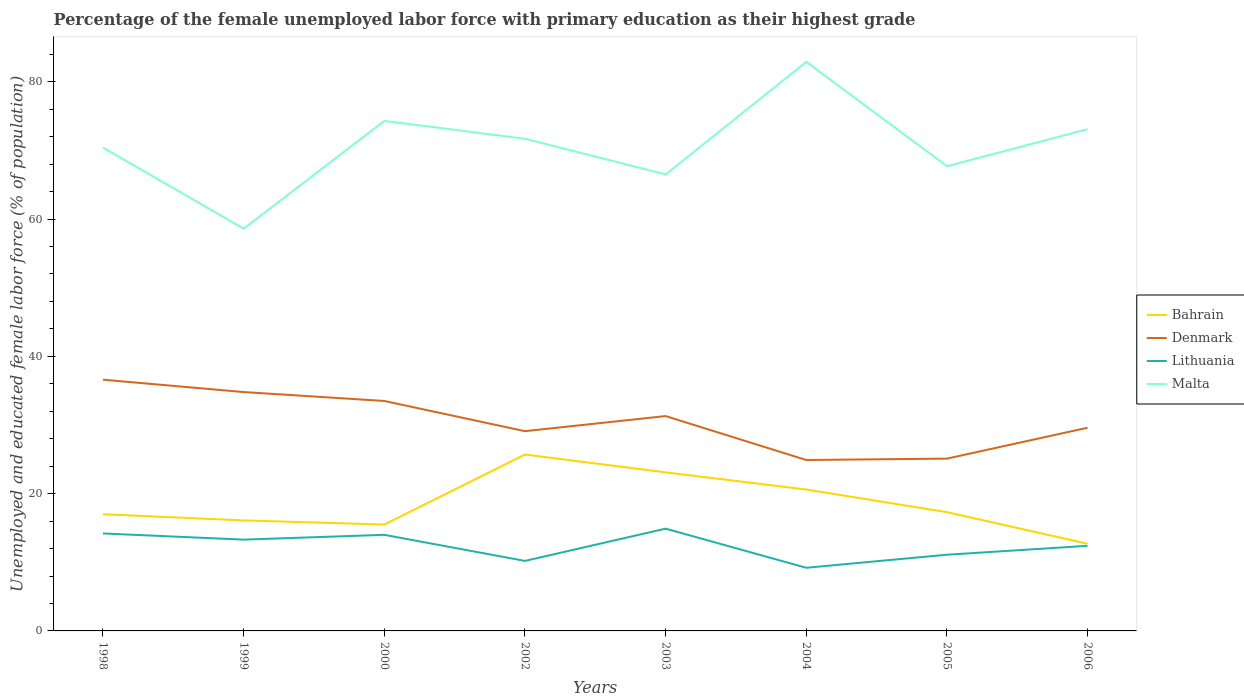How many different coloured lines are there?
Your response must be concise. 4. Across all years, what is the maximum percentage of the unemployed female labor force with primary education in Lithuania?
Make the answer very short. 9.2. In which year was the percentage of the unemployed female labor force with primary education in Malta maximum?
Your answer should be compact. 1999. What is the total percentage of the unemployed female labor force with primary education in Malta in the graph?
Offer a very short reply. -9.1. What is the difference between the highest and the second highest percentage of the unemployed female labor force with primary education in Denmark?
Provide a succinct answer. 11.7. What is the difference between the highest and the lowest percentage of the unemployed female labor force with primary education in Bahrain?
Offer a very short reply. 3. What is the difference between two consecutive major ticks on the Y-axis?
Your response must be concise. 20. Does the graph contain any zero values?
Give a very brief answer. No. What is the title of the graph?
Offer a terse response. Percentage of the female unemployed labor force with primary education as their highest grade. Does "Mali" appear as one of the legend labels in the graph?
Provide a short and direct response. No. What is the label or title of the Y-axis?
Ensure brevity in your answer.  Unemployed and educated female labor force (% of population). What is the Unemployed and educated female labor force (% of population) in Bahrain in 1998?
Offer a terse response. 17. What is the Unemployed and educated female labor force (% of population) in Denmark in 1998?
Give a very brief answer. 36.6. What is the Unemployed and educated female labor force (% of population) in Lithuania in 1998?
Ensure brevity in your answer.  14.2. What is the Unemployed and educated female labor force (% of population) of Malta in 1998?
Keep it short and to the point. 70.4. What is the Unemployed and educated female labor force (% of population) of Bahrain in 1999?
Your answer should be very brief. 16.1. What is the Unemployed and educated female labor force (% of population) in Denmark in 1999?
Offer a terse response. 34.8. What is the Unemployed and educated female labor force (% of population) in Lithuania in 1999?
Give a very brief answer. 13.3. What is the Unemployed and educated female labor force (% of population) of Malta in 1999?
Provide a short and direct response. 58.6. What is the Unemployed and educated female labor force (% of population) of Denmark in 2000?
Make the answer very short. 33.5. What is the Unemployed and educated female labor force (% of population) in Lithuania in 2000?
Give a very brief answer. 14. What is the Unemployed and educated female labor force (% of population) of Malta in 2000?
Provide a succinct answer. 74.3. What is the Unemployed and educated female labor force (% of population) in Bahrain in 2002?
Offer a very short reply. 25.7. What is the Unemployed and educated female labor force (% of population) in Denmark in 2002?
Make the answer very short. 29.1. What is the Unemployed and educated female labor force (% of population) in Lithuania in 2002?
Keep it short and to the point. 10.2. What is the Unemployed and educated female labor force (% of population) of Malta in 2002?
Your response must be concise. 71.7. What is the Unemployed and educated female labor force (% of population) of Bahrain in 2003?
Your answer should be compact. 23.1. What is the Unemployed and educated female labor force (% of population) in Denmark in 2003?
Your answer should be very brief. 31.3. What is the Unemployed and educated female labor force (% of population) in Lithuania in 2003?
Your answer should be very brief. 14.9. What is the Unemployed and educated female labor force (% of population) of Malta in 2003?
Offer a very short reply. 66.5. What is the Unemployed and educated female labor force (% of population) of Bahrain in 2004?
Offer a terse response. 20.6. What is the Unemployed and educated female labor force (% of population) of Denmark in 2004?
Your response must be concise. 24.9. What is the Unemployed and educated female labor force (% of population) in Lithuania in 2004?
Keep it short and to the point. 9.2. What is the Unemployed and educated female labor force (% of population) of Malta in 2004?
Give a very brief answer. 82.9. What is the Unemployed and educated female labor force (% of population) of Bahrain in 2005?
Your response must be concise. 17.3. What is the Unemployed and educated female labor force (% of population) of Denmark in 2005?
Provide a succinct answer. 25.1. What is the Unemployed and educated female labor force (% of population) of Lithuania in 2005?
Your answer should be compact. 11.1. What is the Unemployed and educated female labor force (% of population) in Malta in 2005?
Offer a terse response. 67.7. What is the Unemployed and educated female labor force (% of population) of Bahrain in 2006?
Ensure brevity in your answer.  12.7. What is the Unemployed and educated female labor force (% of population) of Denmark in 2006?
Give a very brief answer. 29.6. What is the Unemployed and educated female labor force (% of population) in Lithuania in 2006?
Provide a succinct answer. 12.4. What is the Unemployed and educated female labor force (% of population) in Malta in 2006?
Provide a succinct answer. 73.1. Across all years, what is the maximum Unemployed and educated female labor force (% of population) in Bahrain?
Offer a terse response. 25.7. Across all years, what is the maximum Unemployed and educated female labor force (% of population) in Denmark?
Provide a short and direct response. 36.6. Across all years, what is the maximum Unemployed and educated female labor force (% of population) of Lithuania?
Make the answer very short. 14.9. Across all years, what is the maximum Unemployed and educated female labor force (% of population) of Malta?
Your answer should be compact. 82.9. Across all years, what is the minimum Unemployed and educated female labor force (% of population) of Bahrain?
Provide a succinct answer. 12.7. Across all years, what is the minimum Unemployed and educated female labor force (% of population) of Denmark?
Make the answer very short. 24.9. Across all years, what is the minimum Unemployed and educated female labor force (% of population) in Lithuania?
Ensure brevity in your answer.  9.2. Across all years, what is the minimum Unemployed and educated female labor force (% of population) in Malta?
Provide a short and direct response. 58.6. What is the total Unemployed and educated female labor force (% of population) in Bahrain in the graph?
Your answer should be compact. 148. What is the total Unemployed and educated female labor force (% of population) in Denmark in the graph?
Your response must be concise. 244.9. What is the total Unemployed and educated female labor force (% of population) in Lithuania in the graph?
Your answer should be compact. 99.3. What is the total Unemployed and educated female labor force (% of population) in Malta in the graph?
Make the answer very short. 565.2. What is the difference between the Unemployed and educated female labor force (% of population) in Denmark in 1998 and that in 1999?
Your answer should be compact. 1.8. What is the difference between the Unemployed and educated female labor force (% of population) of Lithuania in 1998 and that in 1999?
Offer a very short reply. 0.9. What is the difference between the Unemployed and educated female labor force (% of population) of Malta in 1998 and that in 1999?
Make the answer very short. 11.8. What is the difference between the Unemployed and educated female labor force (% of population) in Bahrain in 1998 and that in 2000?
Your answer should be very brief. 1.5. What is the difference between the Unemployed and educated female labor force (% of population) of Malta in 1998 and that in 2000?
Make the answer very short. -3.9. What is the difference between the Unemployed and educated female labor force (% of population) of Bahrain in 1998 and that in 2002?
Keep it short and to the point. -8.7. What is the difference between the Unemployed and educated female labor force (% of population) of Denmark in 1998 and that in 2002?
Give a very brief answer. 7.5. What is the difference between the Unemployed and educated female labor force (% of population) of Denmark in 1998 and that in 2003?
Offer a very short reply. 5.3. What is the difference between the Unemployed and educated female labor force (% of population) of Bahrain in 1998 and that in 2004?
Offer a very short reply. -3.6. What is the difference between the Unemployed and educated female labor force (% of population) of Denmark in 1998 and that in 2004?
Your response must be concise. 11.7. What is the difference between the Unemployed and educated female labor force (% of population) of Lithuania in 1998 and that in 2004?
Provide a short and direct response. 5. What is the difference between the Unemployed and educated female labor force (% of population) of Lithuania in 1998 and that in 2005?
Your answer should be compact. 3.1. What is the difference between the Unemployed and educated female labor force (% of population) in Malta in 1998 and that in 2005?
Provide a succinct answer. 2.7. What is the difference between the Unemployed and educated female labor force (% of population) of Lithuania in 1998 and that in 2006?
Offer a terse response. 1.8. What is the difference between the Unemployed and educated female labor force (% of population) in Malta in 1998 and that in 2006?
Make the answer very short. -2.7. What is the difference between the Unemployed and educated female labor force (% of population) of Lithuania in 1999 and that in 2000?
Provide a succinct answer. -0.7. What is the difference between the Unemployed and educated female labor force (% of population) in Malta in 1999 and that in 2000?
Keep it short and to the point. -15.7. What is the difference between the Unemployed and educated female labor force (% of population) in Denmark in 1999 and that in 2002?
Your answer should be compact. 5.7. What is the difference between the Unemployed and educated female labor force (% of population) in Lithuania in 1999 and that in 2002?
Offer a terse response. 3.1. What is the difference between the Unemployed and educated female labor force (% of population) in Bahrain in 1999 and that in 2003?
Your response must be concise. -7. What is the difference between the Unemployed and educated female labor force (% of population) of Lithuania in 1999 and that in 2003?
Make the answer very short. -1.6. What is the difference between the Unemployed and educated female labor force (% of population) in Bahrain in 1999 and that in 2004?
Your answer should be very brief. -4.5. What is the difference between the Unemployed and educated female labor force (% of population) in Denmark in 1999 and that in 2004?
Your answer should be compact. 9.9. What is the difference between the Unemployed and educated female labor force (% of population) in Malta in 1999 and that in 2004?
Offer a terse response. -24.3. What is the difference between the Unemployed and educated female labor force (% of population) in Lithuania in 1999 and that in 2005?
Offer a very short reply. 2.2. What is the difference between the Unemployed and educated female labor force (% of population) of Malta in 1999 and that in 2005?
Your response must be concise. -9.1. What is the difference between the Unemployed and educated female labor force (% of population) of Denmark in 1999 and that in 2006?
Your answer should be very brief. 5.2. What is the difference between the Unemployed and educated female labor force (% of population) in Malta in 1999 and that in 2006?
Your answer should be compact. -14.5. What is the difference between the Unemployed and educated female labor force (% of population) in Lithuania in 2000 and that in 2002?
Your response must be concise. 3.8. What is the difference between the Unemployed and educated female labor force (% of population) of Malta in 2000 and that in 2002?
Keep it short and to the point. 2.6. What is the difference between the Unemployed and educated female labor force (% of population) of Bahrain in 2000 and that in 2003?
Offer a very short reply. -7.6. What is the difference between the Unemployed and educated female labor force (% of population) of Malta in 2000 and that in 2003?
Your answer should be very brief. 7.8. What is the difference between the Unemployed and educated female labor force (% of population) in Denmark in 2000 and that in 2004?
Offer a terse response. 8.6. What is the difference between the Unemployed and educated female labor force (% of population) in Lithuania in 2000 and that in 2004?
Provide a succinct answer. 4.8. What is the difference between the Unemployed and educated female labor force (% of population) of Malta in 2000 and that in 2004?
Give a very brief answer. -8.6. What is the difference between the Unemployed and educated female labor force (% of population) of Bahrain in 2000 and that in 2006?
Ensure brevity in your answer.  2.8. What is the difference between the Unemployed and educated female labor force (% of population) in Denmark in 2000 and that in 2006?
Offer a terse response. 3.9. What is the difference between the Unemployed and educated female labor force (% of population) of Lithuania in 2002 and that in 2003?
Keep it short and to the point. -4.7. What is the difference between the Unemployed and educated female labor force (% of population) of Malta in 2002 and that in 2003?
Offer a terse response. 5.2. What is the difference between the Unemployed and educated female labor force (% of population) of Denmark in 2002 and that in 2004?
Offer a very short reply. 4.2. What is the difference between the Unemployed and educated female labor force (% of population) in Denmark in 2002 and that in 2005?
Keep it short and to the point. 4. What is the difference between the Unemployed and educated female labor force (% of population) in Malta in 2002 and that in 2005?
Provide a succinct answer. 4. What is the difference between the Unemployed and educated female labor force (% of population) of Bahrain in 2002 and that in 2006?
Offer a terse response. 13. What is the difference between the Unemployed and educated female labor force (% of population) of Lithuania in 2002 and that in 2006?
Provide a succinct answer. -2.2. What is the difference between the Unemployed and educated female labor force (% of population) of Denmark in 2003 and that in 2004?
Keep it short and to the point. 6.4. What is the difference between the Unemployed and educated female labor force (% of population) of Lithuania in 2003 and that in 2004?
Your answer should be compact. 5.7. What is the difference between the Unemployed and educated female labor force (% of population) in Malta in 2003 and that in 2004?
Provide a short and direct response. -16.4. What is the difference between the Unemployed and educated female labor force (% of population) in Lithuania in 2003 and that in 2005?
Provide a succinct answer. 3.8. What is the difference between the Unemployed and educated female labor force (% of population) of Malta in 2003 and that in 2005?
Your answer should be very brief. -1.2. What is the difference between the Unemployed and educated female labor force (% of population) in Bahrain in 2004 and that in 2005?
Your response must be concise. 3.3. What is the difference between the Unemployed and educated female labor force (% of population) in Lithuania in 2004 and that in 2005?
Your response must be concise. -1.9. What is the difference between the Unemployed and educated female labor force (% of population) in Malta in 2004 and that in 2005?
Make the answer very short. 15.2. What is the difference between the Unemployed and educated female labor force (% of population) of Bahrain in 2004 and that in 2006?
Offer a terse response. 7.9. What is the difference between the Unemployed and educated female labor force (% of population) in Denmark in 2004 and that in 2006?
Provide a short and direct response. -4.7. What is the difference between the Unemployed and educated female labor force (% of population) in Lithuania in 2004 and that in 2006?
Your answer should be very brief. -3.2. What is the difference between the Unemployed and educated female labor force (% of population) in Bahrain in 2005 and that in 2006?
Ensure brevity in your answer.  4.6. What is the difference between the Unemployed and educated female labor force (% of population) of Denmark in 2005 and that in 2006?
Ensure brevity in your answer.  -4.5. What is the difference between the Unemployed and educated female labor force (% of population) in Bahrain in 1998 and the Unemployed and educated female labor force (% of population) in Denmark in 1999?
Provide a short and direct response. -17.8. What is the difference between the Unemployed and educated female labor force (% of population) in Bahrain in 1998 and the Unemployed and educated female labor force (% of population) in Malta in 1999?
Make the answer very short. -41.6. What is the difference between the Unemployed and educated female labor force (% of population) of Denmark in 1998 and the Unemployed and educated female labor force (% of population) of Lithuania in 1999?
Your answer should be very brief. 23.3. What is the difference between the Unemployed and educated female labor force (% of population) in Denmark in 1998 and the Unemployed and educated female labor force (% of population) in Malta in 1999?
Give a very brief answer. -22. What is the difference between the Unemployed and educated female labor force (% of population) of Lithuania in 1998 and the Unemployed and educated female labor force (% of population) of Malta in 1999?
Make the answer very short. -44.4. What is the difference between the Unemployed and educated female labor force (% of population) of Bahrain in 1998 and the Unemployed and educated female labor force (% of population) of Denmark in 2000?
Provide a succinct answer. -16.5. What is the difference between the Unemployed and educated female labor force (% of population) of Bahrain in 1998 and the Unemployed and educated female labor force (% of population) of Malta in 2000?
Ensure brevity in your answer.  -57.3. What is the difference between the Unemployed and educated female labor force (% of population) in Denmark in 1998 and the Unemployed and educated female labor force (% of population) in Lithuania in 2000?
Provide a succinct answer. 22.6. What is the difference between the Unemployed and educated female labor force (% of population) of Denmark in 1998 and the Unemployed and educated female labor force (% of population) of Malta in 2000?
Your response must be concise. -37.7. What is the difference between the Unemployed and educated female labor force (% of population) of Lithuania in 1998 and the Unemployed and educated female labor force (% of population) of Malta in 2000?
Ensure brevity in your answer.  -60.1. What is the difference between the Unemployed and educated female labor force (% of population) in Bahrain in 1998 and the Unemployed and educated female labor force (% of population) in Denmark in 2002?
Provide a short and direct response. -12.1. What is the difference between the Unemployed and educated female labor force (% of population) in Bahrain in 1998 and the Unemployed and educated female labor force (% of population) in Malta in 2002?
Offer a terse response. -54.7. What is the difference between the Unemployed and educated female labor force (% of population) of Denmark in 1998 and the Unemployed and educated female labor force (% of population) of Lithuania in 2002?
Offer a very short reply. 26.4. What is the difference between the Unemployed and educated female labor force (% of population) in Denmark in 1998 and the Unemployed and educated female labor force (% of population) in Malta in 2002?
Provide a short and direct response. -35.1. What is the difference between the Unemployed and educated female labor force (% of population) in Lithuania in 1998 and the Unemployed and educated female labor force (% of population) in Malta in 2002?
Keep it short and to the point. -57.5. What is the difference between the Unemployed and educated female labor force (% of population) in Bahrain in 1998 and the Unemployed and educated female labor force (% of population) in Denmark in 2003?
Offer a terse response. -14.3. What is the difference between the Unemployed and educated female labor force (% of population) in Bahrain in 1998 and the Unemployed and educated female labor force (% of population) in Lithuania in 2003?
Give a very brief answer. 2.1. What is the difference between the Unemployed and educated female labor force (% of population) in Bahrain in 1998 and the Unemployed and educated female labor force (% of population) in Malta in 2003?
Provide a succinct answer. -49.5. What is the difference between the Unemployed and educated female labor force (% of population) in Denmark in 1998 and the Unemployed and educated female labor force (% of population) in Lithuania in 2003?
Provide a short and direct response. 21.7. What is the difference between the Unemployed and educated female labor force (% of population) of Denmark in 1998 and the Unemployed and educated female labor force (% of population) of Malta in 2003?
Your response must be concise. -29.9. What is the difference between the Unemployed and educated female labor force (% of population) of Lithuania in 1998 and the Unemployed and educated female labor force (% of population) of Malta in 2003?
Offer a very short reply. -52.3. What is the difference between the Unemployed and educated female labor force (% of population) of Bahrain in 1998 and the Unemployed and educated female labor force (% of population) of Malta in 2004?
Provide a succinct answer. -65.9. What is the difference between the Unemployed and educated female labor force (% of population) of Denmark in 1998 and the Unemployed and educated female labor force (% of population) of Lithuania in 2004?
Your answer should be compact. 27.4. What is the difference between the Unemployed and educated female labor force (% of population) of Denmark in 1998 and the Unemployed and educated female labor force (% of population) of Malta in 2004?
Provide a succinct answer. -46.3. What is the difference between the Unemployed and educated female labor force (% of population) of Lithuania in 1998 and the Unemployed and educated female labor force (% of population) of Malta in 2004?
Make the answer very short. -68.7. What is the difference between the Unemployed and educated female labor force (% of population) in Bahrain in 1998 and the Unemployed and educated female labor force (% of population) in Denmark in 2005?
Your answer should be very brief. -8.1. What is the difference between the Unemployed and educated female labor force (% of population) of Bahrain in 1998 and the Unemployed and educated female labor force (% of population) of Lithuania in 2005?
Your response must be concise. 5.9. What is the difference between the Unemployed and educated female labor force (% of population) of Bahrain in 1998 and the Unemployed and educated female labor force (% of population) of Malta in 2005?
Offer a very short reply. -50.7. What is the difference between the Unemployed and educated female labor force (% of population) of Denmark in 1998 and the Unemployed and educated female labor force (% of population) of Malta in 2005?
Offer a very short reply. -31.1. What is the difference between the Unemployed and educated female labor force (% of population) in Lithuania in 1998 and the Unemployed and educated female labor force (% of population) in Malta in 2005?
Your response must be concise. -53.5. What is the difference between the Unemployed and educated female labor force (% of population) in Bahrain in 1998 and the Unemployed and educated female labor force (% of population) in Lithuania in 2006?
Provide a short and direct response. 4.6. What is the difference between the Unemployed and educated female labor force (% of population) of Bahrain in 1998 and the Unemployed and educated female labor force (% of population) of Malta in 2006?
Offer a terse response. -56.1. What is the difference between the Unemployed and educated female labor force (% of population) in Denmark in 1998 and the Unemployed and educated female labor force (% of population) in Lithuania in 2006?
Your answer should be compact. 24.2. What is the difference between the Unemployed and educated female labor force (% of population) in Denmark in 1998 and the Unemployed and educated female labor force (% of population) in Malta in 2006?
Keep it short and to the point. -36.5. What is the difference between the Unemployed and educated female labor force (% of population) of Lithuania in 1998 and the Unemployed and educated female labor force (% of population) of Malta in 2006?
Make the answer very short. -58.9. What is the difference between the Unemployed and educated female labor force (% of population) in Bahrain in 1999 and the Unemployed and educated female labor force (% of population) in Denmark in 2000?
Your response must be concise. -17.4. What is the difference between the Unemployed and educated female labor force (% of population) of Bahrain in 1999 and the Unemployed and educated female labor force (% of population) of Malta in 2000?
Keep it short and to the point. -58.2. What is the difference between the Unemployed and educated female labor force (% of population) of Denmark in 1999 and the Unemployed and educated female labor force (% of population) of Lithuania in 2000?
Keep it short and to the point. 20.8. What is the difference between the Unemployed and educated female labor force (% of population) of Denmark in 1999 and the Unemployed and educated female labor force (% of population) of Malta in 2000?
Give a very brief answer. -39.5. What is the difference between the Unemployed and educated female labor force (% of population) of Lithuania in 1999 and the Unemployed and educated female labor force (% of population) of Malta in 2000?
Offer a very short reply. -61. What is the difference between the Unemployed and educated female labor force (% of population) of Bahrain in 1999 and the Unemployed and educated female labor force (% of population) of Denmark in 2002?
Your answer should be compact. -13. What is the difference between the Unemployed and educated female labor force (% of population) of Bahrain in 1999 and the Unemployed and educated female labor force (% of population) of Malta in 2002?
Give a very brief answer. -55.6. What is the difference between the Unemployed and educated female labor force (% of population) of Denmark in 1999 and the Unemployed and educated female labor force (% of population) of Lithuania in 2002?
Your response must be concise. 24.6. What is the difference between the Unemployed and educated female labor force (% of population) of Denmark in 1999 and the Unemployed and educated female labor force (% of population) of Malta in 2002?
Provide a short and direct response. -36.9. What is the difference between the Unemployed and educated female labor force (% of population) of Lithuania in 1999 and the Unemployed and educated female labor force (% of population) of Malta in 2002?
Ensure brevity in your answer.  -58.4. What is the difference between the Unemployed and educated female labor force (% of population) in Bahrain in 1999 and the Unemployed and educated female labor force (% of population) in Denmark in 2003?
Give a very brief answer. -15.2. What is the difference between the Unemployed and educated female labor force (% of population) in Bahrain in 1999 and the Unemployed and educated female labor force (% of population) in Lithuania in 2003?
Offer a terse response. 1.2. What is the difference between the Unemployed and educated female labor force (% of population) of Bahrain in 1999 and the Unemployed and educated female labor force (% of population) of Malta in 2003?
Keep it short and to the point. -50.4. What is the difference between the Unemployed and educated female labor force (% of population) in Denmark in 1999 and the Unemployed and educated female labor force (% of population) in Malta in 2003?
Give a very brief answer. -31.7. What is the difference between the Unemployed and educated female labor force (% of population) of Lithuania in 1999 and the Unemployed and educated female labor force (% of population) of Malta in 2003?
Provide a short and direct response. -53.2. What is the difference between the Unemployed and educated female labor force (% of population) in Bahrain in 1999 and the Unemployed and educated female labor force (% of population) in Malta in 2004?
Your answer should be compact. -66.8. What is the difference between the Unemployed and educated female labor force (% of population) in Denmark in 1999 and the Unemployed and educated female labor force (% of population) in Lithuania in 2004?
Provide a succinct answer. 25.6. What is the difference between the Unemployed and educated female labor force (% of population) in Denmark in 1999 and the Unemployed and educated female labor force (% of population) in Malta in 2004?
Provide a short and direct response. -48.1. What is the difference between the Unemployed and educated female labor force (% of population) of Lithuania in 1999 and the Unemployed and educated female labor force (% of population) of Malta in 2004?
Provide a succinct answer. -69.6. What is the difference between the Unemployed and educated female labor force (% of population) of Bahrain in 1999 and the Unemployed and educated female labor force (% of population) of Malta in 2005?
Ensure brevity in your answer.  -51.6. What is the difference between the Unemployed and educated female labor force (% of population) of Denmark in 1999 and the Unemployed and educated female labor force (% of population) of Lithuania in 2005?
Ensure brevity in your answer.  23.7. What is the difference between the Unemployed and educated female labor force (% of population) in Denmark in 1999 and the Unemployed and educated female labor force (% of population) in Malta in 2005?
Your response must be concise. -32.9. What is the difference between the Unemployed and educated female labor force (% of population) of Lithuania in 1999 and the Unemployed and educated female labor force (% of population) of Malta in 2005?
Make the answer very short. -54.4. What is the difference between the Unemployed and educated female labor force (% of population) in Bahrain in 1999 and the Unemployed and educated female labor force (% of population) in Malta in 2006?
Keep it short and to the point. -57. What is the difference between the Unemployed and educated female labor force (% of population) of Denmark in 1999 and the Unemployed and educated female labor force (% of population) of Lithuania in 2006?
Make the answer very short. 22.4. What is the difference between the Unemployed and educated female labor force (% of population) of Denmark in 1999 and the Unemployed and educated female labor force (% of population) of Malta in 2006?
Offer a very short reply. -38.3. What is the difference between the Unemployed and educated female labor force (% of population) in Lithuania in 1999 and the Unemployed and educated female labor force (% of population) in Malta in 2006?
Provide a short and direct response. -59.8. What is the difference between the Unemployed and educated female labor force (% of population) of Bahrain in 2000 and the Unemployed and educated female labor force (% of population) of Lithuania in 2002?
Your answer should be very brief. 5.3. What is the difference between the Unemployed and educated female labor force (% of population) of Bahrain in 2000 and the Unemployed and educated female labor force (% of population) of Malta in 2002?
Offer a very short reply. -56.2. What is the difference between the Unemployed and educated female labor force (% of population) of Denmark in 2000 and the Unemployed and educated female labor force (% of population) of Lithuania in 2002?
Give a very brief answer. 23.3. What is the difference between the Unemployed and educated female labor force (% of population) of Denmark in 2000 and the Unemployed and educated female labor force (% of population) of Malta in 2002?
Ensure brevity in your answer.  -38.2. What is the difference between the Unemployed and educated female labor force (% of population) in Lithuania in 2000 and the Unemployed and educated female labor force (% of population) in Malta in 2002?
Offer a terse response. -57.7. What is the difference between the Unemployed and educated female labor force (% of population) in Bahrain in 2000 and the Unemployed and educated female labor force (% of population) in Denmark in 2003?
Offer a very short reply. -15.8. What is the difference between the Unemployed and educated female labor force (% of population) in Bahrain in 2000 and the Unemployed and educated female labor force (% of population) in Lithuania in 2003?
Provide a short and direct response. 0.6. What is the difference between the Unemployed and educated female labor force (% of population) in Bahrain in 2000 and the Unemployed and educated female labor force (% of population) in Malta in 2003?
Your answer should be compact. -51. What is the difference between the Unemployed and educated female labor force (% of population) of Denmark in 2000 and the Unemployed and educated female labor force (% of population) of Malta in 2003?
Keep it short and to the point. -33. What is the difference between the Unemployed and educated female labor force (% of population) of Lithuania in 2000 and the Unemployed and educated female labor force (% of population) of Malta in 2003?
Your answer should be very brief. -52.5. What is the difference between the Unemployed and educated female labor force (% of population) of Bahrain in 2000 and the Unemployed and educated female labor force (% of population) of Denmark in 2004?
Give a very brief answer. -9.4. What is the difference between the Unemployed and educated female labor force (% of population) of Bahrain in 2000 and the Unemployed and educated female labor force (% of population) of Lithuania in 2004?
Provide a short and direct response. 6.3. What is the difference between the Unemployed and educated female labor force (% of population) of Bahrain in 2000 and the Unemployed and educated female labor force (% of population) of Malta in 2004?
Offer a very short reply. -67.4. What is the difference between the Unemployed and educated female labor force (% of population) in Denmark in 2000 and the Unemployed and educated female labor force (% of population) in Lithuania in 2004?
Offer a terse response. 24.3. What is the difference between the Unemployed and educated female labor force (% of population) of Denmark in 2000 and the Unemployed and educated female labor force (% of population) of Malta in 2004?
Give a very brief answer. -49.4. What is the difference between the Unemployed and educated female labor force (% of population) of Lithuania in 2000 and the Unemployed and educated female labor force (% of population) of Malta in 2004?
Your answer should be very brief. -68.9. What is the difference between the Unemployed and educated female labor force (% of population) in Bahrain in 2000 and the Unemployed and educated female labor force (% of population) in Denmark in 2005?
Offer a very short reply. -9.6. What is the difference between the Unemployed and educated female labor force (% of population) of Bahrain in 2000 and the Unemployed and educated female labor force (% of population) of Lithuania in 2005?
Ensure brevity in your answer.  4.4. What is the difference between the Unemployed and educated female labor force (% of population) in Bahrain in 2000 and the Unemployed and educated female labor force (% of population) in Malta in 2005?
Keep it short and to the point. -52.2. What is the difference between the Unemployed and educated female labor force (% of population) in Denmark in 2000 and the Unemployed and educated female labor force (% of population) in Lithuania in 2005?
Offer a very short reply. 22.4. What is the difference between the Unemployed and educated female labor force (% of population) in Denmark in 2000 and the Unemployed and educated female labor force (% of population) in Malta in 2005?
Your response must be concise. -34.2. What is the difference between the Unemployed and educated female labor force (% of population) in Lithuania in 2000 and the Unemployed and educated female labor force (% of population) in Malta in 2005?
Your answer should be compact. -53.7. What is the difference between the Unemployed and educated female labor force (% of population) in Bahrain in 2000 and the Unemployed and educated female labor force (% of population) in Denmark in 2006?
Offer a terse response. -14.1. What is the difference between the Unemployed and educated female labor force (% of population) in Bahrain in 2000 and the Unemployed and educated female labor force (% of population) in Malta in 2006?
Make the answer very short. -57.6. What is the difference between the Unemployed and educated female labor force (% of population) of Denmark in 2000 and the Unemployed and educated female labor force (% of population) of Lithuania in 2006?
Offer a very short reply. 21.1. What is the difference between the Unemployed and educated female labor force (% of population) in Denmark in 2000 and the Unemployed and educated female labor force (% of population) in Malta in 2006?
Your answer should be compact. -39.6. What is the difference between the Unemployed and educated female labor force (% of population) in Lithuania in 2000 and the Unemployed and educated female labor force (% of population) in Malta in 2006?
Your answer should be compact. -59.1. What is the difference between the Unemployed and educated female labor force (% of population) of Bahrain in 2002 and the Unemployed and educated female labor force (% of population) of Denmark in 2003?
Provide a short and direct response. -5.6. What is the difference between the Unemployed and educated female labor force (% of population) in Bahrain in 2002 and the Unemployed and educated female labor force (% of population) in Malta in 2003?
Give a very brief answer. -40.8. What is the difference between the Unemployed and educated female labor force (% of population) in Denmark in 2002 and the Unemployed and educated female labor force (% of population) in Malta in 2003?
Offer a terse response. -37.4. What is the difference between the Unemployed and educated female labor force (% of population) of Lithuania in 2002 and the Unemployed and educated female labor force (% of population) of Malta in 2003?
Offer a terse response. -56.3. What is the difference between the Unemployed and educated female labor force (% of population) in Bahrain in 2002 and the Unemployed and educated female labor force (% of population) in Malta in 2004?
Provide a short and direct response. -57.2. What is the difference between the Unemployed and educated female labor force (% of population) in Denmark in 2002 and the Unemployed and educated female labor force (% of population) in Lithuania in 2004?
Ensure brevity in your answer.  19.9. What is the difference between the Unemployed and educated female labor force (% of population) in Denmark in 2002 and the Unemployed and educated female labor force (% of population) in Malta in 2004?
Your answer should be compact. -53.8. What is the difference between the Unemployed and educated female labor force (% of population) of Lithuania in 2002 and the Unemployed and educated female labor force (% of population) of Malta in 2004?
Ensure brevity in your answer.  -72.7. What is the difference between the Unemployed and educated female labor force (% of population) of Bahrain in 2002 and the Unemployed and educated female labor force (% of population) of Denmark in 2005?
Offer a very short reply. 0.6. What is the difference between the Unemployed and educated female labor force (% of population) of Bahrain in 2002 and the Unemployed and educated female labor force (% of population) of Lithuania in 2005?
Offer a terse response. 14.6. What is the difference between the Unemployed and educated female labor force (% of population) in Bahrain in 2002 and the Unemployed and educated female labor force (% of population) in Malta in 2005?
Your answer should be compact. -42. What is the difference between the Unemployed and educated female labor force (% of population) of Denmark in 2002 and the Unemployed and educated female labor force (% of population) of Lithuania in 2005?
Your response must be concise. 18. What is the difference between the Unemployed and educated female labor force (% of population) in Denmark in 2002 and the Unemployed and educated female labor force (% of population) in Malta in 2005?
Ensure brevity in your answer.  -38.6. What is the difference between the Unemployed and educated female labor force (% of population) in Lithuania in 2002 and the Unemployed and educated female labor force (% of population) in Malta in 2005?
Give a very brief answer. -57.5. What is the difference between the Unemployed and educated female labor force (% of population) of Bahrain in 2002 and the Unemployed and educated female labor force (% of population) of Denmark in 2006?
Your answer should be very brief. -3.9. What is the difference between the Unemployed and educated female labor force (% of population) of Bahrain in 2002 and the Unemployed and educated female labor force (% of population) of Malta in 2006?
Ensure brevity in your answer.  -47.4. What is the difference between the Unemployed and educated female labor force (% of population) of Denmark in 2002 and the Unemployed and educated female labor force (% of population) of Malta in 2006?
Provide a succinct answer. -44. What is the difference between the Unemployed and educated female labor force (% of population) of Lithuania in 2002 and the Unemployed and educated female labor force (% of population) of Malta in 2006?
Offer a terse response. -62.9. What is the difference between the Unemployed and educated female labor force (% of population) of Bahrain in 2003 and the Unemployed and educated female labor force (% of population) of Denmark in 2004?
Your answer should be very brief. -1.8. What is the difference between the Unemployed and educated female labor force (% of population) of Bahrain in 2003 and the Unemployed and educated female labor force (% of population) of Lithuania in 2004?
Give a very brief answer. 13.9. What is the difference between the Unemployed and educated female labor force (% of population) in Bahrain in 2003 and the Unemployed and educated female labor force (% of population) in Malta in 2004?
Offer a very short reply. -59.8. What is the difference between the Unemployed and educated female labor force (% of population) of Denmark in 2003 and the Unemployed and educated female labor force (% of population) of Lithuania in 2004?
Keep it short and to the point. 22.1. What is the difference between the Unemployed and educated female labor force (% of population) of Denmark in 2003 and the Unemployed and educated female labor force (% of population) of Malta in 2004?
Offer a very short reply. -51.6. What is the difference between the Unemployed and educated female labor force (% of population) of Lithuania in 2003 and the Unemployed and educated female labor force (% of population) of Malta in 2004?
Your response must be concise. -68. What is the difference between the Unemployed and educated female labor force (% of population) in Bahrain in 2003 and the Unemployed and educated female labor force (% of population) in Denmark in 2005?
Ensure brevity in your answer.  -2. What is the difference between the Unemployed and educated female labor force (% of population) in Bahrain in 2003 and the Unemployed and educated female labor force (% of population) in Malta in 2005?
Provide a succinct answer. -44.6. What is the difference between the Unemployed and educated female labor force (% of population) of Denmark in 2003 and the Unemployed and educated female labor force (% of population) of Lithuania in 2005?
Ensure brevity in your answer.  20.2. What is the difference between the Unemployed and educated female labor force (% of population) in Denmark in 2003 and the Unemployed and educated female labor force (% of population) in Malta in 2005?
Make the answer very short. -36.4. What is the difference between the Unemployed and educated female labor force (% of population) in Lithuania in 2003 and the Unemployed and educated female labor force (% of population) in Malta in 2005?
Give a very brief answer. -52.8. What is the difference between the Unemployed and educated female labor force (% of population) in Bahrain in 2003 and the Unemployed and educated female labor force (% of population) in Denmark in 2006?
Provide a short and direct response. -6.5. What is the difference between the Unemployed and educated female labor force (% of population) of Bahrain in 2003 and the Unemployed and educated female labor force (% of population) of Lithuania in 2006?
Your response must be concise. 10.7. What is the difference between the Unemployed and educated female labor force (% of population) in Bahrain in 2003 and the Unemployed and educated female labor force (% of population) in Malta in 2006?
Make the answer very short. -50. What is the difference between the Unemployed and educated female labor force (% of population) in Denmark in 2003 and the Unemployed and educated female labor force (% of population) in Malta in 2006?
Your answer should be compact. -41.8. What is the difference between the Unemployed and educated female labor force (% of population) in Lithuania in 2003 and the Unemployed and educated female labor force (% of population) in Malta in 2006?
Offer a very short reply. -58.2. What is the difference between the Unemployed and educated female labor force (% of population) in Bahrain in 2004 and the Unemployed and educated female labor force (% of population) in Denmark in 2005?
Your answer should be very brief. -4.5. What is the difference between the Unemployed and educated female labor force (% of population) of Bahrain in 2004 and the Unemployed and educated female labor force (% of population) of Lithuania in 2005?
Ensure brevity in your answer.  9.5. What is the difference between the Unemployed and educated female labor force (% of population) of Bahrain in 2004 and the Unemployed and educated female labor force (% of population) of Malta in 2005?
Your answer should be very brief. -47.1. What is the difference between the Unemployed and educated female labor force (% of population) of Denmark in 2004 and the Unemployed and educated female labor force (% of population) of Lithuania in 2005?
Make the answer very short. 13.8. What is the difference between the Unemployed and educated female labor force (% of population) in Denmark in 2004 and the Unemployed and educated female labor force (% of population) in Malta in 2005?
Your answer should be compact. -42.8. What is the difference between the Unemployed and educated female labor force (% of population) in Lithuania in 2004 and the Unemployed and educated female labor force (% of population) in Malta in 2005?
Keep it short and to the point. -58.5. What is the difference between the Unemployed and educated female labor force (% of population) in Bahrain in 2004 and the Unemployed and educated female labor force (% of population) in Denmark in 2006?
Ensure brevity in your answer.  -9. What is the difference between the Unemployed and educated female labor force (% of population) of Bahrain in 2004 and the Unemployed and educated female labor force (% of population) of Lithuania in 2006?
Ensure brevity in your answer.  8.2. What is the difference between the Unemployed and educated female labor force (% of population) of Bahrain in 2004 and the Unemployed and educated female labor force (% of population) of Malta in 2006?
Offer a terse response. -52.5. What is the difference between the Unemployed and educated female labor force (% of population) in Denmark in 2004 and the Unemployed and educated female labor force (% of population) in Malta in 2006?
Your answer should be compact. -48.2. What is the difference between the Unemployed and educated female labor force (% of population) of Lithuania in 2004 and the Unemployed and educated female labor force (% of population) of Malta in 2006?
Keep it short and to the point. -63.9. What is the difference between the Unemployed and educated female labor force (% of population) of Bahrain in 2005 and the Unemployed and educated female labor force (% of population) of Denmark in 2006?
Ensure brevity in your answer.  -12.3. What is the difference between the Unemployed and educated female labor force (% of population) of Bahrain in 2005 and the Unemployed and educated female labor force (% of population) of Lithuania in 2006?
Provide a short and direct response. 4.9. What is the difference between the Unemployed and educated female labor force (% of population) of Bahrain in 2005 and the Unemployed and educated female labor force (% of population) of Malta in 2006?
Your answer should be compact. -55.8. What is the difference between the Unemployed and educated female labor force (% of population) in Denmark in 2005 and the Unemployed and educated female labor force (% of population) in Lithuania in 2006?
Provide a short and direct response. 12.7. What is the difference between the Unemployed and educated female labor force (% of population) of Denmark in 2005 and the Unemployed and educated female labor force (% of population) of Malta in 2006?
Give a very brief answer. -48. What is the difference between the Unemployed and educated female labor force (% of population) in Lithuania in 2005 and the Unemployed and educated female labor force (% of population) in Malta in 2006?
Provide a succinct answer. -62. What is the average Unemployed and educated female labor force (% of population) in Denmark per year?
Keep it short and to the point. 30.61. What is the average Unemployed and educated female labor force (% of population) of Lithuania per year?
Provide a succinct answer. 12.41. What is the average Unemployed and educated female labor force (% of population) in Malta per year?
Offer a very short reply. 70.65. In the year 1998, what is the difference between the Unemployed and educated female labor force (% of population) of Bahrain and Unemployed and educated female labor force (% of population) of Denmark?
Provide a short and direct response. -19.6. In the year 1998, what is the difference between the Unemployed and educated female labor force (% of population) of Bahrain and Unemployed and educated female labor force (% of population) of Lithuania?
Provide a short and direct response. 2.8. In the year 1998, what is the difference between the Unemployed and educated female labor force (% of population) in Bahrain and Unemployed and educated female labor force (% of population) in Malta?
Give a very brief answer. -53.4. In the year 1998, what is the difference between the Unemployed and educated female labor force (% of population) of Denmark and Unemployed and educated female labor force (% of population) of Lithuania?
Your answer should be very brief. 22.4. In the year 1998, what is the difference between the Unemployed and educated female labor force (% of population) of Denmark and Unemployed and educated female labor force (% of population) of Malta?
Provide a succinct answer. -33.8. In the year 1998, what is the difference between the Unemployed and educated female labor force (% of population) of Lithuania and Unemployed and educated female labor force (% of population) of Malta?
Offer a very short reply. -56.2. In the year 1999, what is the difference between the Unemployed and educated female labor force (% of population) of Bahrain and Unemployed and educated female labor force (% of population) of Denmark?
Keep it short and to the point. -18.7. In the year 1999, what is the difference between the Unemployed and educated female labor force (% of population) of Bahrain and Unemployed and educated female labor force (% of population) of Lithuania?
Offer a very short reply. 2.8. In the year 1999, what is the difference between the Unemployed and educated female labor force (% of population) of Bahrain and Unemployed and educated female labor force (% of population) of Malta?
Your answer should be compact. -42.5. In the year 1999, what is the difference between the Unemployed and educated female labor force (% of population) of Denmark and Unemployed and educated female labor force (% of population) of Malta?
Ensure brevity in your answer.  -23.8. In the year 1999, what is the difference between the Unemployed and educated female labor force (% of population) in Lithuania and Unemployed and educated female labor force (% of population) in Malta?
Provide a succinct answer. -45.3. In the year 2000, what is the difference between the Unemployed and educated female labor force (% of population) in Bahrain and Unemployed and educated female labor force (% of population) in Denmark?
Offer a very short reply. -18. In the year 2000, what is the difference between the Unemployed and educated female labor force (% of population) in Bahrain and Unemployed and educated female labor force (% of population) in Malta?
Give a very brief answer. -58.8. In the year 2000, what is the difference between the Unemployed and educated female labor force (% of population) of Denmark and Unemployed and educated female labor force (% of population) of Lithuania?
Provide a succinct answer. 19.5. In the year 2000, what is the difference between the Unemployed and educated female labor force (% of population) in Denmark and Unemployed and educated female labor force (% of population) in Malta?
Make the answer very short. -40.8. In the year 2000, what is the difference between the Unemployed and educated female labor force (% of population) in Lithuania and Unemployed and educated female labor force (% of population) in Malta?
Make the answer very short. -60.3. In the year 2002, what is the difference between the Unemployed and educated female labor force (% of population) of Bahrain and Unemployed and educated female labor force (% of population) of Denmark?
Offer a very short reply. -3.4. In the year 2002, what is the difference between the Unemployed and educated female labor force (% of population) of Bahrain and Unemployed and educated female labor force (% of population) of Malta?
Give a very brief answer. -46. In the year 2002, what is the difference between the Unemployed and educated female labor force (% of population) in Denmark and Unemployed and educated female labor force (% of population) in Malta?
Provide a succinct answer. -42.6. In the year 2002, what is the difference between the Unemployed and educated female labor force (% of population) in Lithuania and Unemployed and educated female labor force (% of population) in Malta?
Provide a short and direct response. -61.5. In the year 2003, what is the difference between the Unemployed and educated female labor force (% of population) of Bahrain and Unemployed and educated female labor force (% of population) of Lithuania?
Ensure brevity in your answer.  8.2. In the year 2003, what is the difference between the Unemployed and educated female labor force (% of population) in Bahrain and Unemployed and educated female labor force (% of population) in Malta?
Your answer should be very brief. -43.4. In the year 2003, what is the difference between the Unemployed and educated female labor force (% of population) of Denmark and Unemployed and educated female labor force (% of population) of Lithuania?
Make the answer very short. 16.4. In the year 2003, what is the difference between the Unemployed and educated female labor force (% of population) in Denmark and Unemployed and educated female labor force (% of population) in Malta?
Your response must be concise. -35.2. In the year 2003, what is the difference between the Unemployed and educated female labor force (% of population) in Lithuania and Unemployed and educated female labor force (% of population) in Malta?
Make the answer very short. -51.6. In the year 2004, what is the difference between the Unemployed and educated female labor force (% of population) of Bahrain and Unemployed and educated female labor force (% of population) of Lithuania?
Your response must be concise. 11.4. In the year 2004, what is the difference between the Unemployed and educated female labor force (% of population) in Bahrain and Unemployed and educated female labor force (% of population) in Malta?
Your answer should be very brief. -62.3. In the year 2004, what is the difference between the Unemployed and educated female labor force (% of population) of Denmark and Unemployed and educated female labor force (% of population) of Malta?
Your response must be concise. -58. In the year 2004, what is the difference between the Unemployed and educated female labor force (% of population) in Lithuania and Unemployed and educated female labor force (% of population) in Malta?
Ensure brevity in your answer.  -73.7. In the year 2005, what is the difference between the Unemployed and educated female labor force (% of population) in Bahrain and Unemployed and educated female labor force (% of population) in Malta?
Make the answer very short. -50.4. In the year 2005, what is the difference between the Unemployed and educated female labor force (% of population) in Denmark and Unemployed and educated female labor force (% of population) in Malta?
Your answer should be compact. -42.6. In the year 2005, what is the difference between the Unemployed and educated female labor force (% of population) in Lithuania and Unemployed and educated female labor force (% of population) in Malta?
Ensure brevity in your answer.  -56.6. In the year 2006, what is the difference between the Unemployed and educated female labor force (% of population) of Bahrain and Unemployed and educated female labor force (% of population) of Denmark?
Your answer should be compact. -16.9. In the year 2006, what is the difference between the Unemployed and educated female labor force (% of population) in Bahrain and Unemployed and educated female labor force (% of population) in Malta?
Your answer should be compact. -60.4. In the year 2006, what is the difference between the Unemployed and educated female labor force (% of population) of Denmark and Unemployed and educated female labor force (% of population) of Lithuania?
Make the answer very short. 17.2. In the year 2006, what is the difference between the Unemployed and educated female labor force (% of population) of Denmark and Unemployed and educated female labor force (% of population) of Malta?
Your answer should be very brief. -43.5. In the year 2006, what is the difference between the Unemployed and educated female labor force (% of population) in Lithuania and Unemployed and educated female labor force (% of population) in Malta?
Provide a short and direct response. -60.7. What is the ratio of the Unemployed and educated female labor force (% of population) of Bahrain in 1998 to that in 1999?
Your response must be concise. 1.06. What is the ratio of the Unemployed and educated female labor force (% of population) of Denmark in 1998 to that in 1999?
Give a very brief answer. 1.05. What is the ratio of the Unemployed and educated female labor force (% of population) of Lithuania in 1998 to that in 1999?
Your answer should be compact. 1.07. What is the ratio of the Unemployed and educated female labor force (% of population) of Malta in 1998 to that in 1999?
Make the answer very short. 1.2. What is the ratio of the Unemployed and educated female labor force (% of population) of Bahrain in 1998 to that in 2000?
Provide a short and direct response. 1.1. What is the ratio of the Unemployed and educated female labor force (% of population) of Denmark in 1998 to that in 2000?
Your answer should be compact. 1.09. What is the ratio of the Unemployed and educated female labor force (% of population) in Lithuania in 1998 to that in 2000?
Give a very brief answer. 1.01. What is the ratio of the Unemployed and educated female labor force (% of population) of Malta in 1998 to that in 2000?
Provide a succinct answer. 0.95. What is the ratio of the Unemployed and educated female labor force (% of population) of Bahrain in 1998 to that in 2002?
Make the answer very short. 0.66. What is the ratio of the Unemployed and educated female labor force (% of population) of Denmark in 1998 to that in 2002?
Offer a very short reply. 1.26. What is the ratio of the Unemployed and educated female labor force (% of population) in Lithuania in 1998 to that in 2002?
Provide a short and direct response. 1.39. What is the ratio of the Unemployed and educated female labor force (% of population) in Malta in 1998 to that in 2002?
Your answer should be compact. 0.98. What is the ratio of the Unemployed and educated female labor force (% of population) of Bahrain in 1998 to that in 2003?
Offer a very short reply. 0.74. What is the ratio of the Unemployed and educated female labor force (% of population) of Denmark in 1998 to that in 2003?
Ensure brevity in your answer.  1.17. What is the ratio of the Unemployed and educated female labor force (% of population) in Lithuania in 1998 to that in 2003?
Your answer should be compact. 0.95. What is the ratio of the Unemployed and educated female labor force (% of population) in Malta in 1998 to that in 2003?
Your response must be concise. 1.06. What is the ratio of the Unemployed and educated female labor force (% of population) of Bahrain in 1998 to that in 2004?
Offer a terse response. 0.83. What is the ratio of the Unemployed and educated female labor force (% of population) in Denmark in 1998 to that in 2004?
Offer a very short reply. 1.47. What is the ratio of the Unemployed and educated female labor force (% of population) of Lithuania in 1998 to that in 2004?
Give a very brief answer. 1.54. What is the ratio of the Unemployed and educated female labor force (% of population) of Malta in 1998 to that in 2004?
Offer a very short reply. 0.85. What is the ratio of the Unemployed and educated female labor force (% of population) in Bahrain in 1998 to that in 2005?
Offer a terse response. 0.98. What is the ratio of the Unemployed and educated female labor force (% of population) in Denmark in 1998 to that in 2005?
Provide a succinct answer. 1.46. What is the ratio of the Unemployed and educated female labor force (% of population) in Lithuania in 1998 to that in 2005?
Your answer should be compact. 1.28. What is the ratio of the Unemployed and educated female labor force (% of population) in Malta in 1998 to that in 2005?
Provide a succinct answer. 1.04. What is the ratio of the Unemployed and educated female labor force (% of population) in Bahrain in 1998 to that in 2006?
Your response must be concise. 1.34. What is the ratio of the Unemployed and educated female labor force (% of population) in Denmark in 1998 to that in 2006?
Offer a terse response. 1.24. What is the ratio of the Unemployed and educated female labor force (% of population) of Lithuania in 1998 to that in 2006?
Your answer should be very brief. 1.15. What is the ratio of the Unemployed and educated female labor force (% of population) of Malta in 1998 to that in 2006?
Give a very brief answer. 0.96. What is the ratio of the Unemployed and educated female labor force (% of population) of Bahrain in 1999 to that in 2000?
Give a very brief answer. 1.04. What is the ratio of the Unemployed and educated female labor force (% of population) in Denmark in 1999 to that in 2000?
Provide a succinct answer. 1.04. What is the ratio of the Unemployed and educated female labor force (% of population) of Malta in 1999 to that in 2000?
Keep it short and to the point. 0.79. What is the ratio of the Unemployed and educated female labor force (% of population) in Bahrain in 1999 to that in 2002?
Make the answer very short. 0.63. What is the ratio of the Unemployed and educated female labor force (% of population) in Denmark in 1999 to that in 2002?
Make the answer very short. 1.2. What is the ratio of the Unemployed and educated female labor force (% of population) in Lithuania in 1999 to that in 2002?
Give a very brief answer. 1.3. What is the ratio of the Unemployed and educated female labor force (% of population) of Malta in 1999 to that in 2002?
Your answer should be compact. 0.82. What is the ratio of the Unemployed and educated female labor force (% of population) in Bahrain in 1999 to that in 2003?
Offer a terse response. 0.7. What is the ratio of the Unemployed and educated female labor force (% of population) in Denmark in 1999 to that in 2003?
Your response must be concise. 1.11. What is the ratio of the Unemployed and educated female labor force (% of population) of Lithuania in 1999 to that in 2003?
Keep it short and to the point. 0.89. What is the ratio of the Unemployed and educated female labor force (% of population) of Malta in 1999 to that in 2003?
Keep it short and to the point. 0.88. What is the ratio of the Unemployed and educated female labor force (% of population) of Bahrain in 1999 to that in 2004?
Your answer should be very brief. 0.78. What is the ratio of the Unemployed and educated female labor force (% of population) in Denmark in 1999 to that in 2004?
Your answer should be compact. 1.4. What is the ratio of the Unemployed and educated female labor force (% of population) in Lithuania in 1999 to that in 2004?
Your response must be concise. 1.45. What is the ratio of the Unemployed and educated female labor force (% of population) in Malta in 1999 to that in 2004?
Your response must be concise. 0.71. What is the ratio of the Unemployed and educated female labor force (% of population) in Bahrain in 1999 to that in 2005?
Offer a very short reply. 0.93. What is the ratio of the Unemployed and educated female labor force (% of population) of Denmark in 1999 to that in 2005?
Ensure brevity in your answer.  1.39. What is the ratio of the Unemployed and educated female labor force (% of population) in Lithuania in 1999 to that in 2005?
Provide a succinct answer. 1.2. What is the ratio of the Unemployed and educated female labor force (% of population) in Malta in 1999 to that in 2005?
Keep it short and to the point. 0.87. What is the ratio of the Unemployed and educated female labor force (% of population) of Bahrain in 1999 to that in 2006?
Your answer should be very brief. 1.27. What is the ratio of the Unemployed and educated female labor force (% of population) of Denmark in 1999 to that in 2006?
Provide a succinct answer. 1.18. What is the ratio of the Unemployed and educated female labor force (% of population) of Lithuania in 1999 to that in 2006?
Your answer should be compact. 1.07. What is the ratio of the Unemployed and educated female labor force (% of population) in Malta in 1999 to that in 2006?
Your response must be concise. 0.8. What is the ratio of the Unemployed and educated female labor force (% of population) in Bahrain in 2000 to that in 2002?
Give a very brief answer. 0.6. What is the ratio of the Unemployed and educated female labor force (% of population) of Denmark in 2000 to that in 2002?
Your answer should be very brief. 1.15. What is the ratio of the Unemployed and educated female labor force (% of population) of Lithuania in 2000 to that in 2002?
Your answer should be compact. 1.37. What is the ratio of the Unemployed and educated female labor force (% of population) in Malta in 2000 to that in 2002?
Your response must be concise. 1.04. What is the ratio of the Unemployed and educated female labor force (% of population) in Bahrain in 2000 to that in 2003?
Your answer should be compact. 0.67. What is the ratio of the Unemployed and educated female labor force (% of population) in Denmark in 2000 to that in 2003?
Offer a terse response. 1.07. What is the ratio of the Unemployed and educated female labor force (% of population) in Lithuania in 2000 to that in 2003?
Keep it short and to the point. 0.94. What is the ratio of the Unemployed and educated female labor force (% of population) in Malta in 2000 to that in 2003?
Provide a short and direct response. 1.12. What is the ratio of the Unemployed and educated female labor force (% of population) of Bahrain in 2000 to that in 2004?
Offer a very short reply. 0.75. What is the ratio of the Unemployed and educated female labor force (% of population) of Denmark in 2000 to that in 2004?
Provide a succinct answer. 1.35. What is the ratio of the Unemployed and educated female labor force (% of population) in Lithuania in 2000 to that in 2004?
Offer a very short reply. 1.52. What is the ratio of the Unemployed and educated female labor force (% of population) in Malta in 2000 to that in 2004?
Your answer should be very brief. 0.9. What is the ratio of the Unemployed and educated female labor force (% of population) of Bahrain in 2000 to that in 2005?
Your response must be concise. 0.9. What is the ratio of the Unemployed and educated female labor force (% of population) in Denmark in 2000 to that in 2005?
Keep it short and to the point. 1.33. What is the ratio of the Unemployed and educated female labor force (% of population) in Lithuania in 2000 to that in 2005?
Provide a succinct answer. 1.26. What is the ratio of the Unemployed and educated female labor force (% of population) in Malta in 2000 to that in 2005?
Provide a succinct answer. 1.1. What is the ratio of the Unemployed and educated female labor force (% of population) in Bahrain in 2000 to that in 2006?
Give a very brief answer. 1.22. What is the ratio of the Unemployed and educated female labor force (% of population) in Denmark in 2000 to that in 2006?
Your answer should be compact. 1.13. What is the ratio of the Unemployed and educated female labor force (% of population) of Lithuania in 2000 to that in 2006?
Your response must be concise. 1.13. What is the ratio of the Unemployed and educated female labor force (% of population) of Malta in 2000 to that in 2006?
Offer a terse response. 1.02. What is the ratio of the Unemployed and educated female labor force (% of population) in Bahrain in 2002 to that in 2003?
Provide a succinct answer. 1.11. What is the ratio of the Unemployed and educated female labor force (% of population) of Denmark in 2002 to that in 2003?
Ensure brevity in your answer.  0.93. What is the ratio of the Unemployed and educated female labor force (% of population) in Lithuania in 2002 to that in 2003?
Provide a succinct answer. 0.68. What is the ratio of the Unemployed and educated female labor force (% of population) in Malta in 2002 to that in 2003?
Make the answer very short. 1.08. What is the ratio of the Unemployed and educated female labor force (% of population) of Bahrain in 2002 to that in 2004?
Give a very brief answer. 1.25. What is the ratio of the Unemployed and educated female labor force (% of population) of Denmark in 2002 to that in 2004?
Your answer should be compact. 1.17. What is the ratio of the Unemployed and educated female labor force (% of population) in Lithuania in 2002 to that in 2004?
Your answer should be very brief. 1.11. What is the ratio of the Unemployed and educated female labor force (% of population) in Malta in 2002 to that in 2004?
Provide a succinct answer. 0.86. What is the ratio of the Unemployed and educated female labor force (% of population) of Bahrain in 2002 to that in 2005?
Give a very brief answer. 1.49. What is the ratio of the Unemployed and educated female labor force (% of population) of Denmark in 2002 to that in 2005?
Keep it short and to the point. 1.16. What is the ratio of the Unemployed and educated female labor force (% of population) in Lithuania in 2002 to that in 2005?
Keep it short and to the point. 0.92. What is the ratio of the Unemployed and educated female labor force (% of population) in Malta in 2002 to that in 2005?
Make the answer very short. 1.06. What is the ratio of the Unemployed and educated female labor force (% of population) in Bahrain in 2002 to that in 2006?
Make the answer very short. 2.02. What is the ratio of the Unemployed and educated female labor force (% of population) of Denmark in 2002 to that in 2006?
Ensure brevity in your answer.  0.98. What is the ratio of the Unemployed and educated female labor force (% of population) in Lithuania in 2002 to that in 2006?
Ensure brevity in your answer.  0.82. What is the ratio of the Unemployed and educated female labor force (% of population) in Malta in 2002 to that in 2006?
Make the answer very short. 0.98. What is the ratio of the Unemployed and educated female labor force (% of population) in Bahrain in 2003 to that in 2004?
Provide a succinct answer. 1.12. What is the ratio of the Unemployed and educated female labor force (% of population) of Denmark in 2003 to that in 2004?
Your answer should be very brief. 1.26. What is the ratio of the Unemployed and educated female labor force (% of population) of Lithuania in 2003 to that in 2004?
Make the answer very short. 1.62. What is the ratio of the Unemployed and educated female labor force (% of population) in Malta in 2003 to that in 2004?
Ensure brevity in your answer.  0.8. What is the ratio of the Unemployed and educated female labor force (% of population) of Bahrain in 2003 to that in 2005?
Your answer should be compact. 1.34. What is the ratio of the Unemployed and educated female labor force (% of population) in Denmark in 2003 to that in 2005?
Provide a succinct answer. 1.25. What is the ratio of the Unemployed and educated female labor force (% of population) of Lithuania in 2003 to that in 2005?
Offer a terse response. 1.34. What is the ratio of the Unemployed and educated female labor force (% of population) in Malta in 2003 to that in 2005?
Offer a terse response. 0.98. What is the ratio of the Unemployed and educated female labor force (% of population) in Bahrain in 2003 to that in 2006?
Your response must be concise. 1.82. What is the ratio of the Unemployed and educated female labor force (% of population) in Denmark in 2003 to that in 2006?
Make the answer very short. 1.06. What is the ratio of the Unemployed and educated female labor force (% of population) in Lithuania in 2003 to that in 2006?
Your answer should be compact. 1.2. What is the ratio of the Unemployed and educated female labor force (% of population) of Malta in 2003 to that in 2006?
Offer a terse response. 0.91. What is the ratio of the Unemployed and educated female labor force (% of population) in Bahrain in 2004 to that in 2005?
Offer a very short reply. 1.19. What is the ratio of the Unemployed and educated female labor force (% of population) of Lithuania in 2004 to that in 2005?
Offer a terse response. 0.83. What is the ratio of the Unemployed and educated female labor force (% of population) in Malta in 2004 to that in 2005?
Provide a succinct answer. 1.22. What is the ratio of the Unemployed and educated female labor force (% of population) in Bahrain in 2004 to that in 2006?
Keep it short and to the point. 1.62. What is the ratio of the Unemployed and educated female labor force (% of population) of Denmark in 2004 to that in 2006?
Make the answer very short. 0.84. What is the ratio of the Unemployed and educated female labor force (% of population) of Lithuania in 2004 to that in 2006?
Provide a succinct answer. 0.74. What is the ratio of the Unemployed and educated female labor force (% of population) of Malta in 2004 to that in 2006?
Provide a short and direct response. 1.13. What is the ratio of the Unemployed and educated female labor force (% of population) in Bahrain in 2005 to that in 2006?
Provide a short and direct response. 1.36. What is the ratio of the Unemployed and educated female labor force (% of population) of Denmark in 2005 to that in 2006?
Your answer should be compact. 0.85. What is the ratio of the Unemployed and educated female labor force (% of population) of Lithuania in 2005 to that in 2006?
Provide a succinct answer. 0.9. What is the ratio of the Unemployed and educated female labor force (% of population) of Malta in 2005 to that in 2006?
Provide a short and direct response. 0.93. What is the difference between the highest and the second highest Unemployed and educated female labor force (% of population) in Bahrain?
Provide a short and direct response. 2.6. What is the difference between the highest and the lowest Unemployed and educated female labor force (% of population) of Bahrain?
Provide a succinct answer. 13. What is the difference between the highest and the lowest Unemployed and educated female labor force (% of population) of Malta?
Offer a terse response. 24.3. 